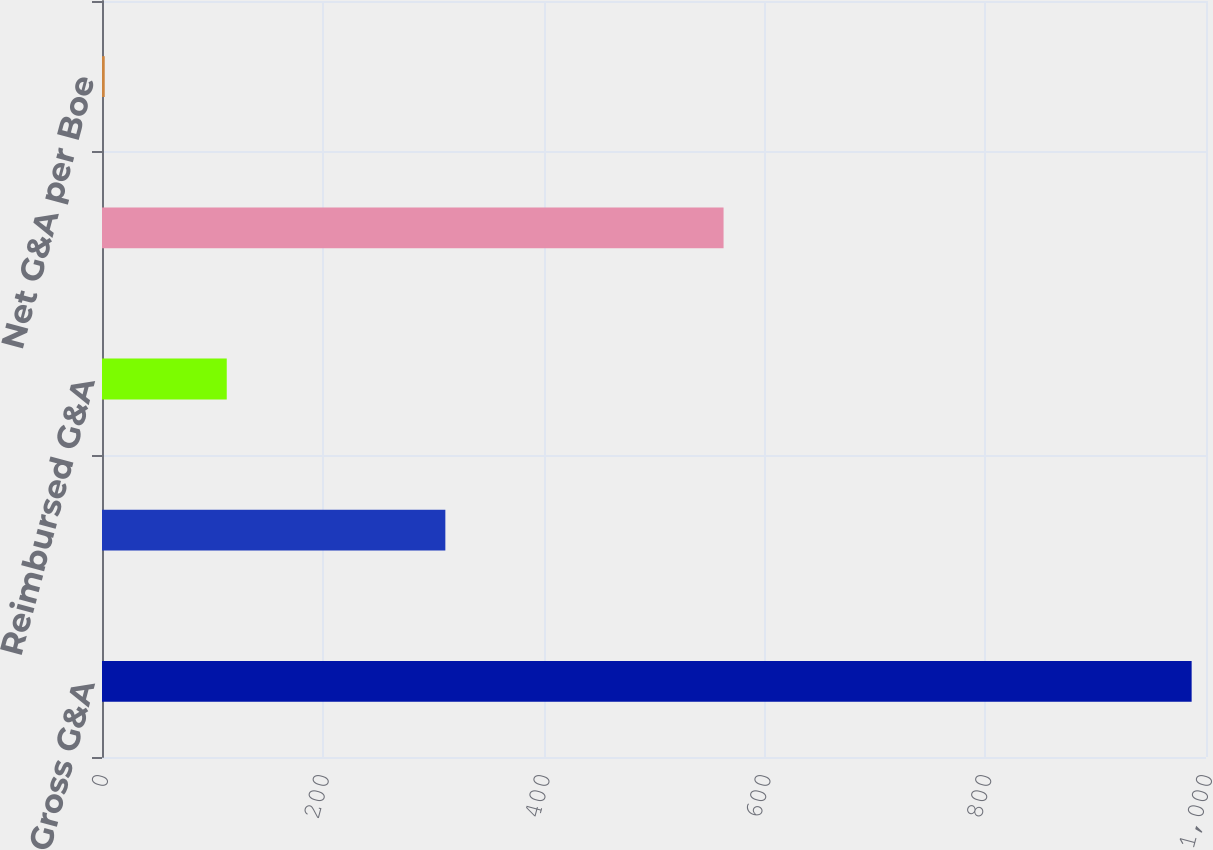Convert chart to OTSL. <chart><loc_0><loc_0><loc_500><loc_500><bar_chart><fcel>Gross G&A<fcel>Capitalized G&A<fcel>Reimbursed G&A<fcel>Net G&A<fcel>Net G&A per Boe<nl><fcel>987<fcel>311<fcel>113<fcel>563<fcel>2.47<nl></chart> 